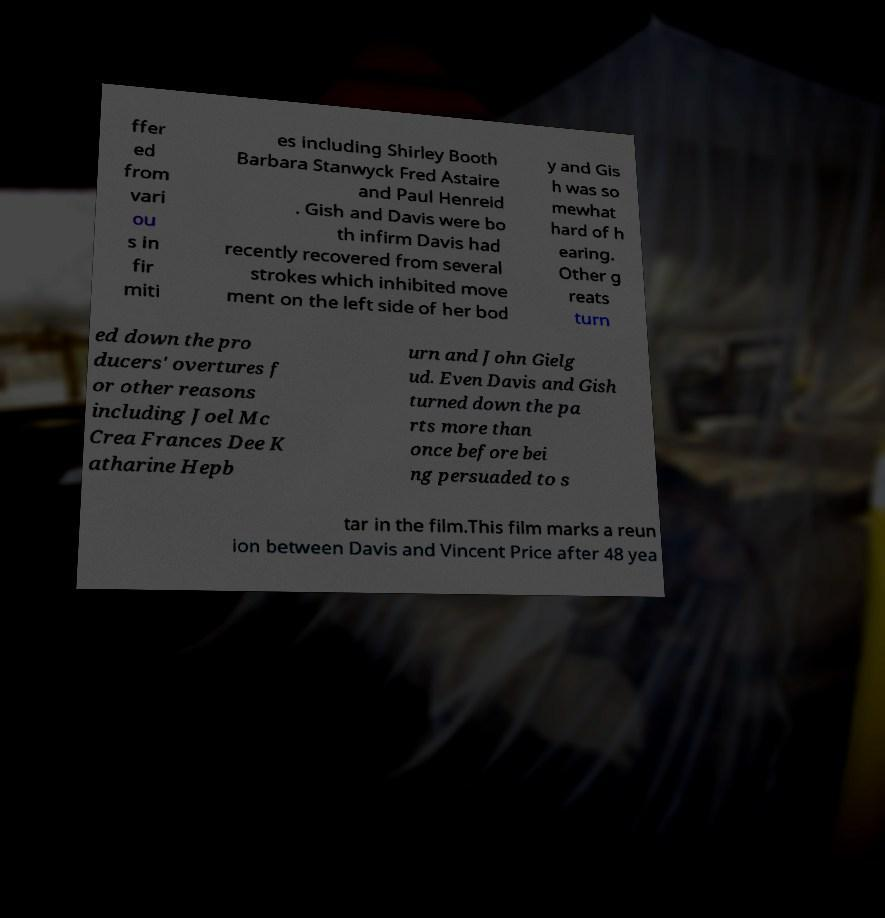Can you accurately transcribe the text from the provided image for me? ffer ed from vari ou s in fir miti es including Shirley Booth Barbara Stanwyck Fred Astaire and Paul Henreid . Gish and Davis were bo th infirm Davis had recently recovered from several strokes which inhibited move ment on the left side of her bod y and Gis h was so mewhat hard of h earing. Other g reats turn ed down the pro ducers' overtures f or other reasons including Joel Mc Crea Frances Dee K atharine Hepb urn and John Gielg ud. Even Davis and Gish turned down the pa rts more than once before bei ng persuaded to s tar in the film.This film marks a reun ion between Davis and Vincent Price after 48 yea 